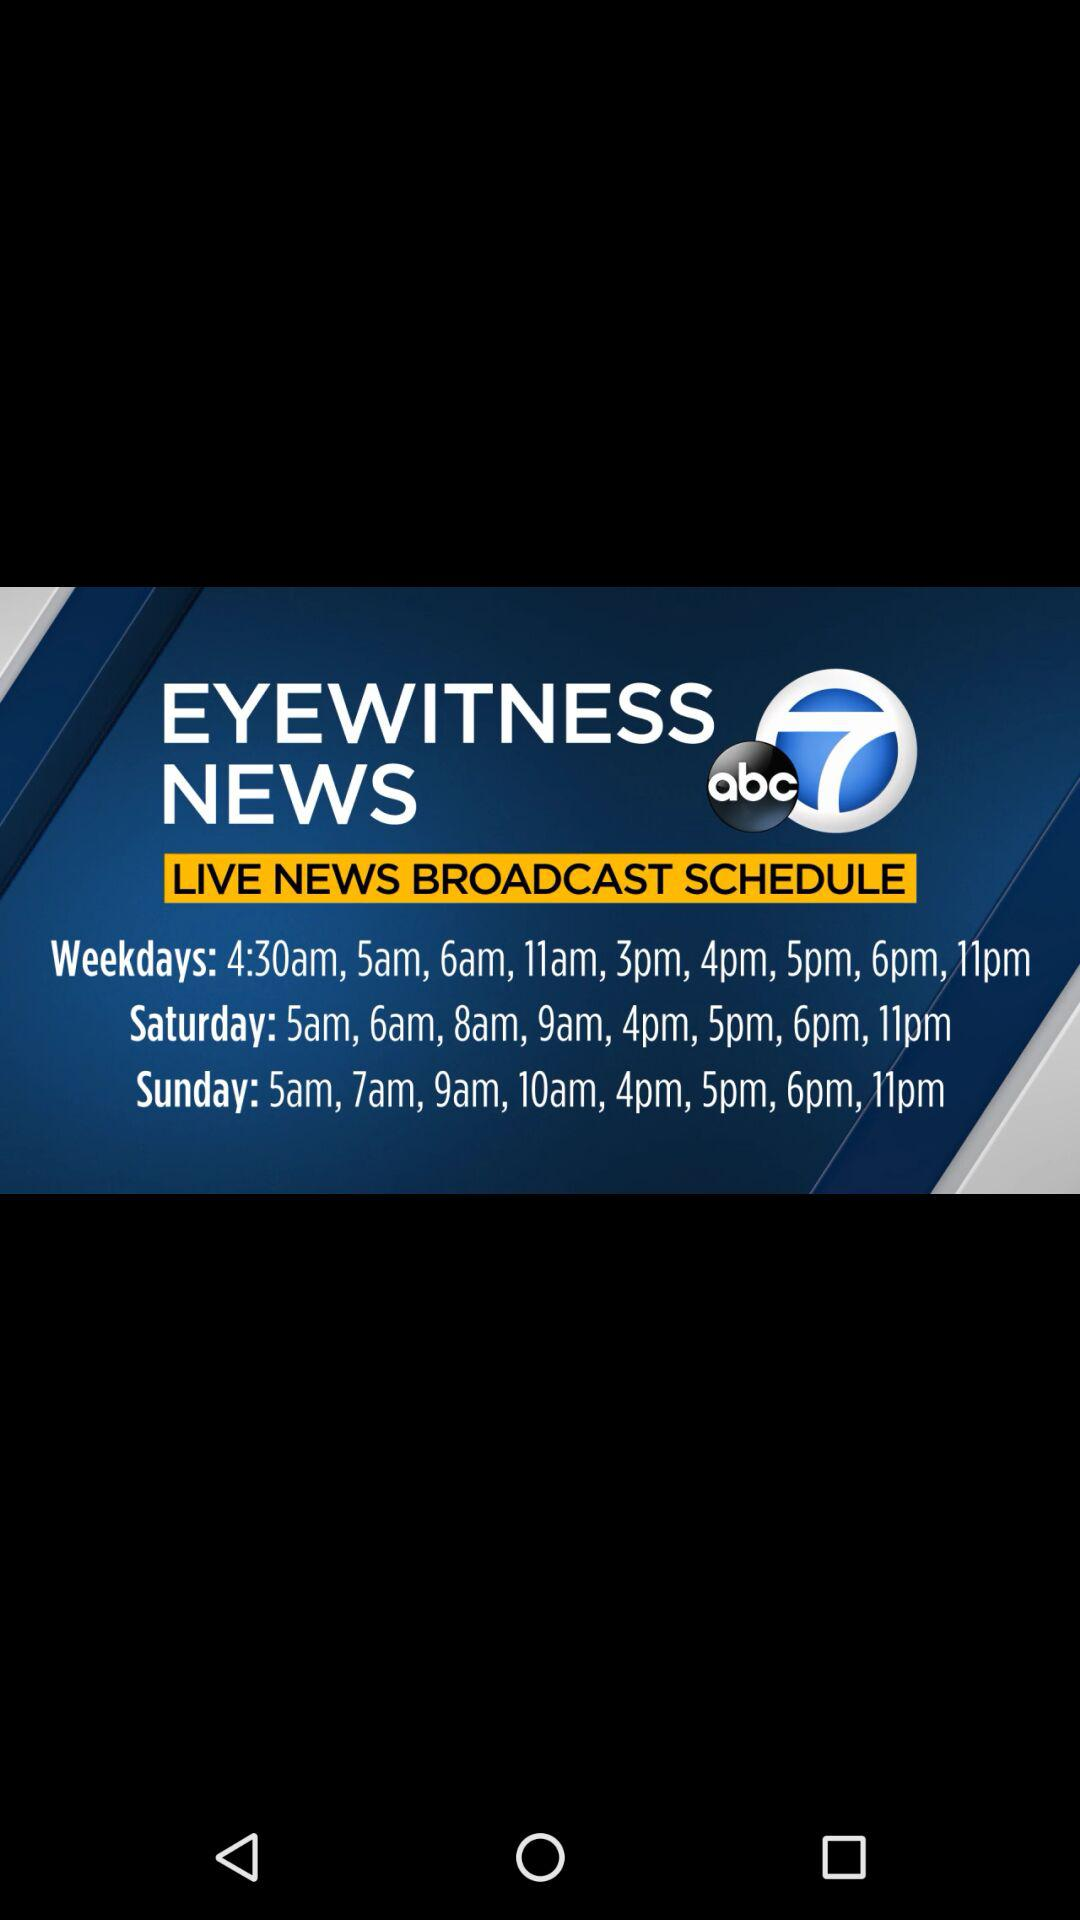When was the live news broadcast schedule posted?
When the provided information is insufficient, respond with <no answer>. <no answer> 